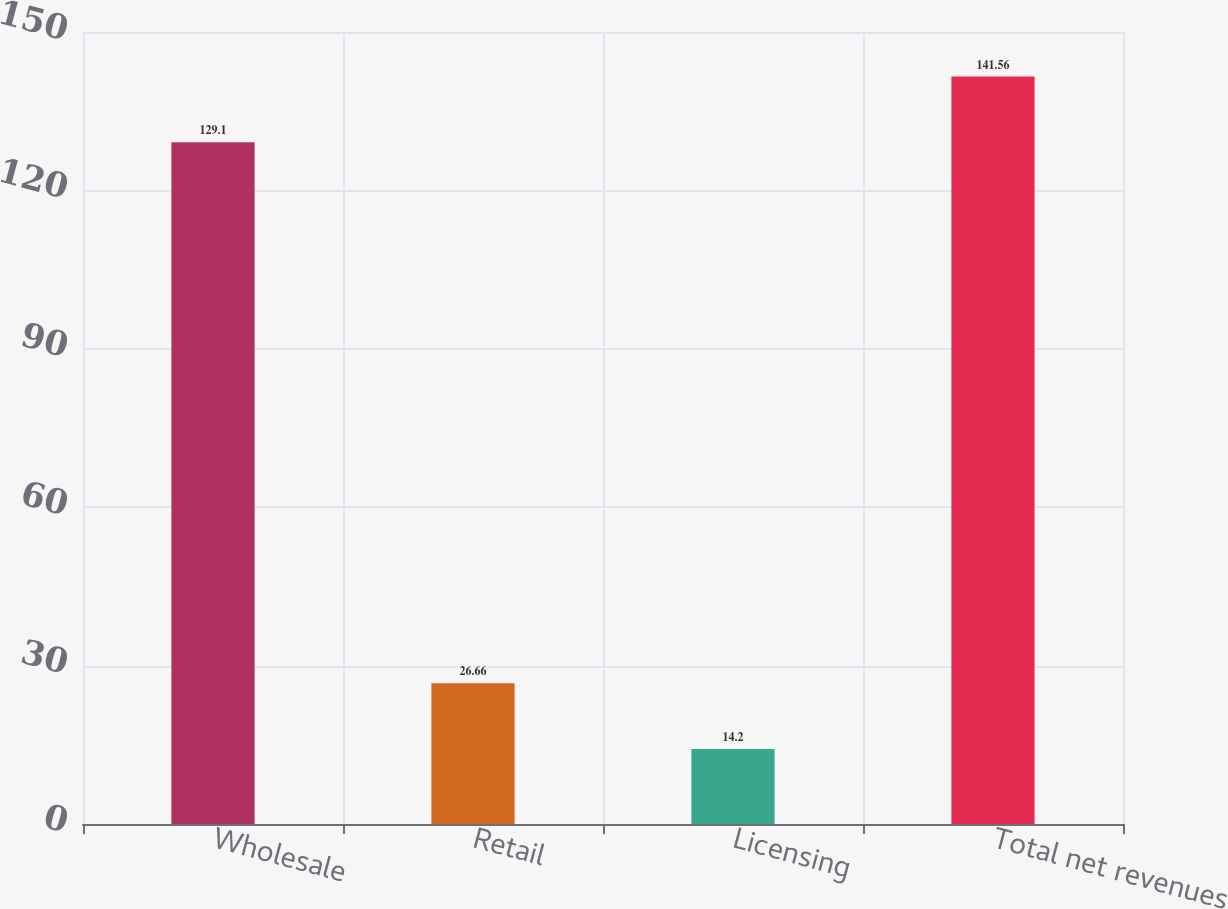Convert chart. <chart><loc_0><loc_0><loc_500><loc_500><bar_chart><fcel>Wholesale<fcel>Retail<fcel>Licensing<fcel>Total net revenues<nl><fcel>129.1<fcel>26.66<fcel>14.2<fcel>141.56<nl></chart> 